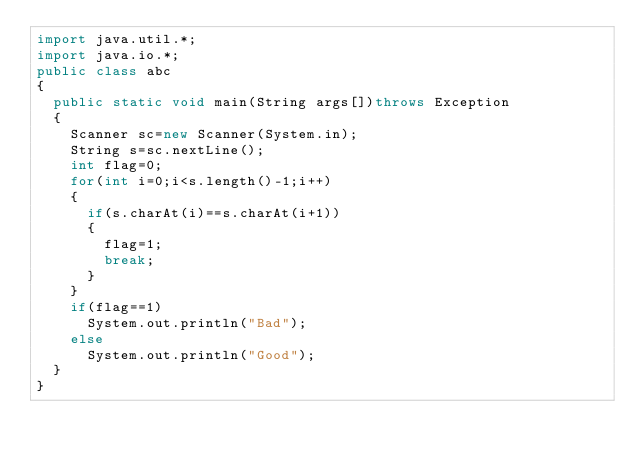Convert code to text. <code><loc_0><loc_0><loc_500><loc_500><_Java_>import java.util.*;
import java.io.*;
public class abc
{
  public static void main(String args[])throws Exception
  {
    Scanner sc=new Scanner(System.in);
    String s=sc.nextLine();
    int flag=0;
    for(int i=0;i<s.length()-1;i++)
    {
      if(s.charAt(i)==s.charAt(i+1))
      {
        flag=1;
        break;
      }
    }
    if(flag==1)
      System.out.println("Bad");
    else
      System.out.println("Good");
  }
}</code> 